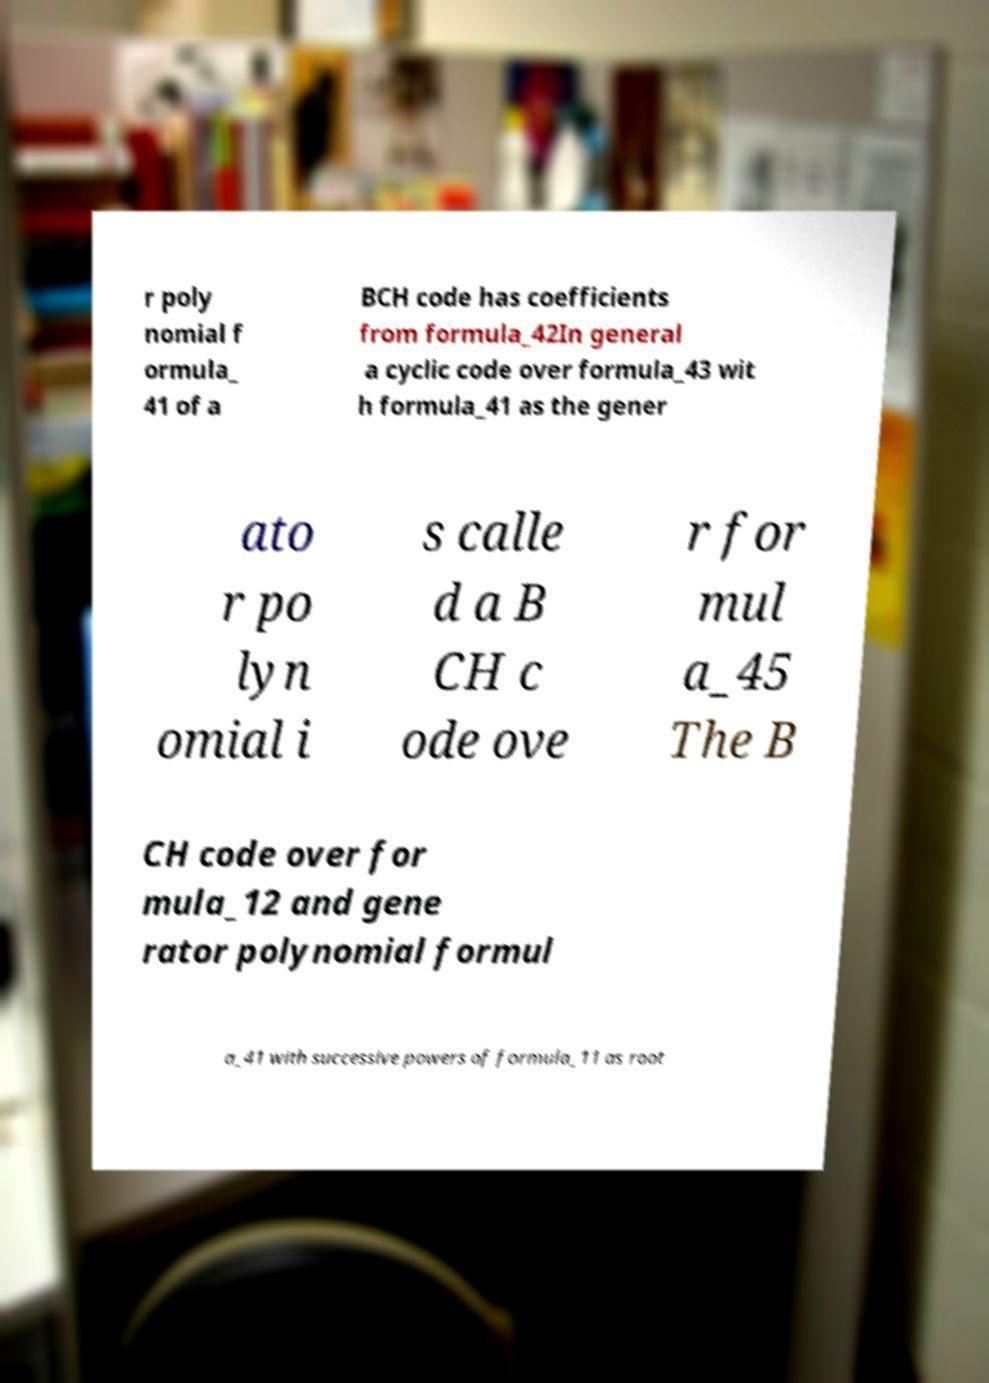Please read and relay the text visible in this image. What does it say? r poly nomial f ormula_ 41 of a BCH code has coefficients from formula_42In general a cyclic code over formula_43 wit h formula_41 as the gener ato r po lyn omial i s calle d a B CH c ode ove r for mul a_45 The B CH code over for mula_12 and gene rator polynomial formul a_41 with successive powers of formula_11 as root 